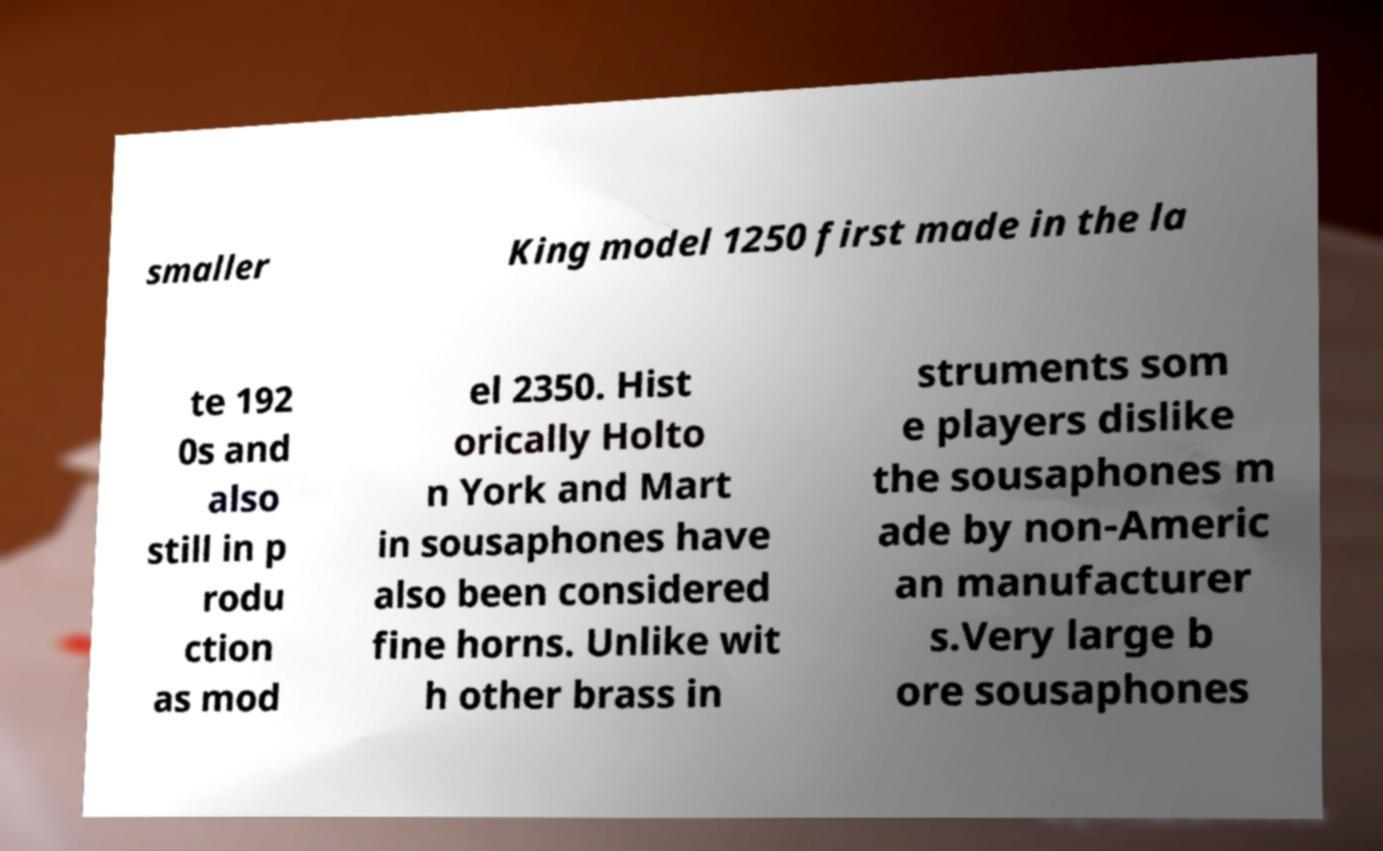Please identify and transcribe the text found in this image. smaller King model 1250 first made in the la te 192 0s and also still in p rodu ction as mod el 2350. Hist orically Holto n York and Mart in sousaphones have also been considered fine horns. Unlike wit h other brass in struments som e players dislike the sousaphones m ade by non-Americ an manufacturer s.Very large b ore sousaphones 